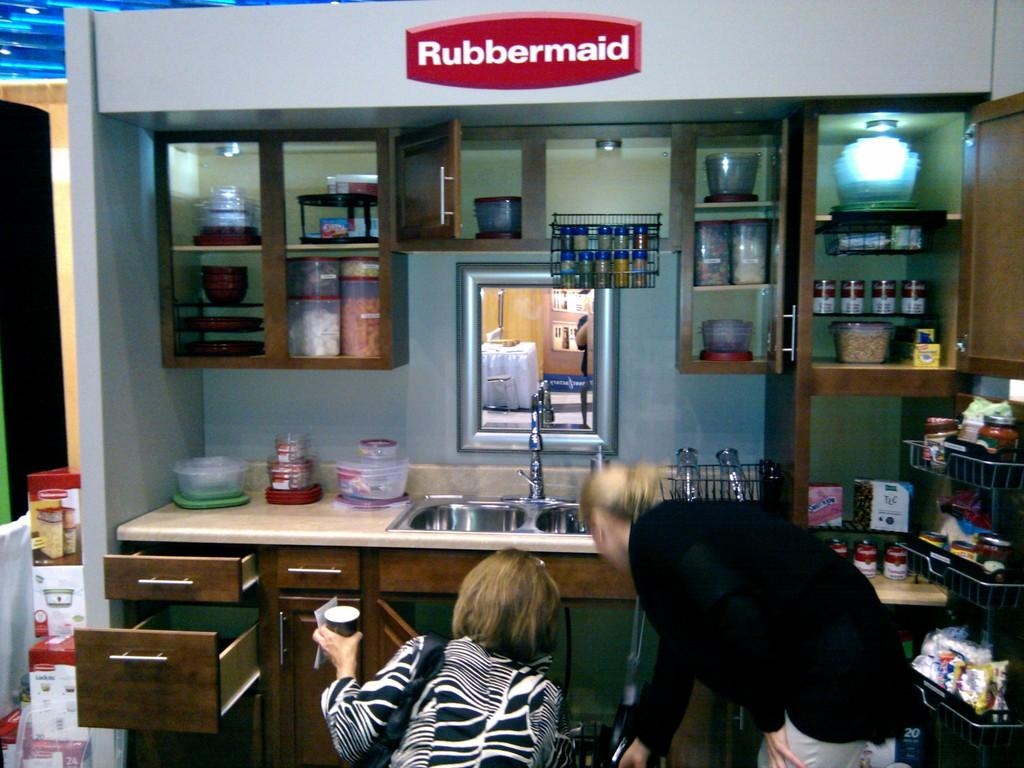<image>
Present a compact description of the photo's key features. two women in front of a kitchen with the logo for rubbertmaid on the top section. 